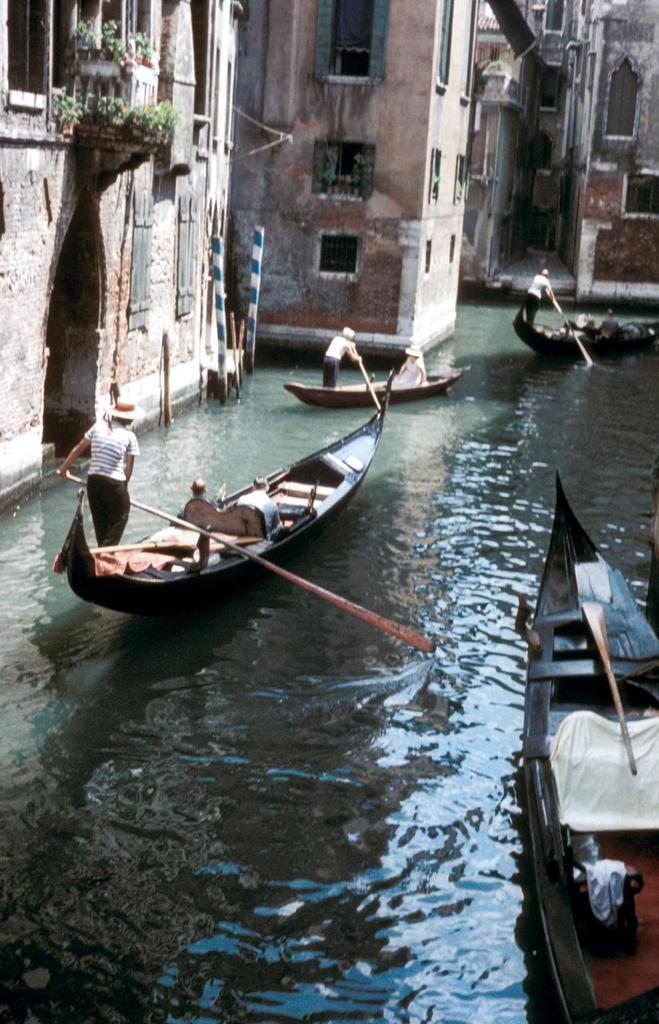Please provide a concise description of this image. In this image we can see boats and persons rowing in the river. Beside the river we can see buildings, windows and plants. 